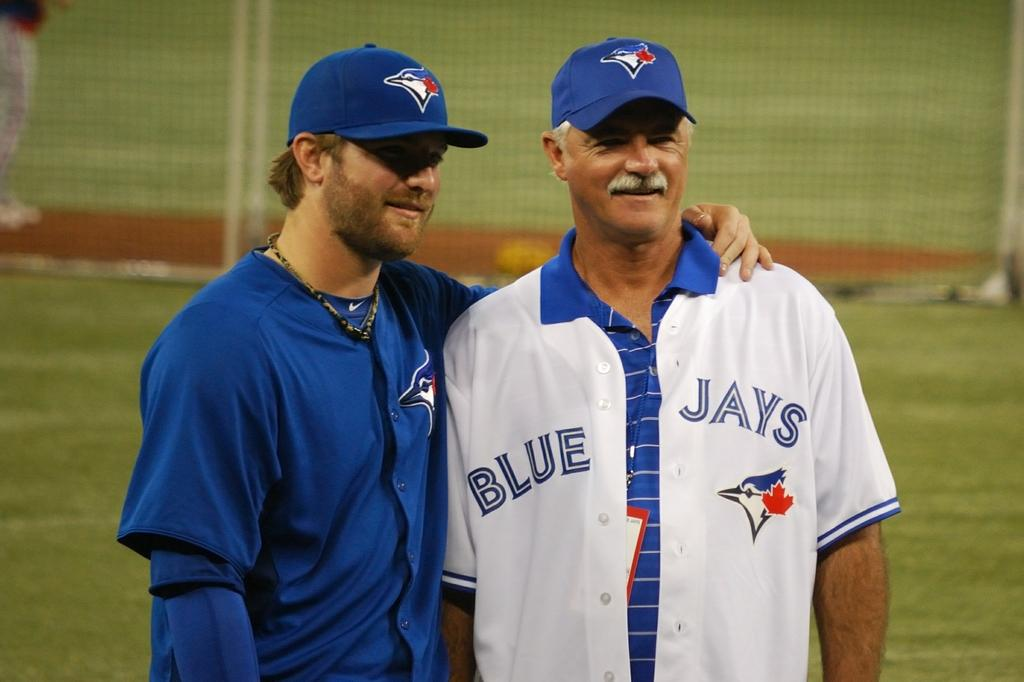<image>
Share a concise interpretation of the image provided. a man standing next to another with a Blue Jays jersey on 